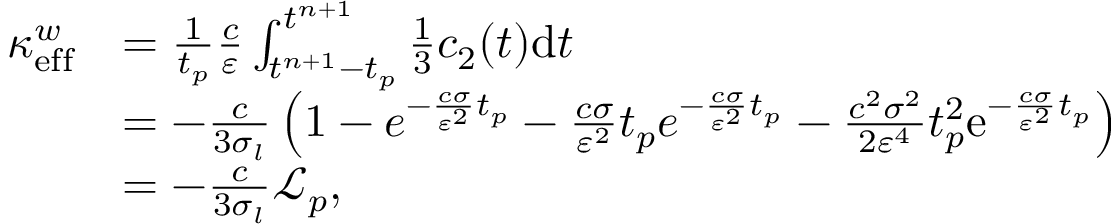Convert formula to latex. <formula><loc_0><loc_0><loc_500><loc_500>\begin{array} { r l } { \kappa _ { e f f } ^ { w } } & { = \frac { 1 } { t _ { p } } \frac { c } { \varepsilon } \int _ { t ^ { n + 1 } - t _ { p } } ^ { t ^ { n + 1 } } \frac { 1 } { 3 } c _ { 2 } ( t ) d t } \\ & { = - \frac { c } { 3 \sigma _ { l } } \left ( 1 - e ^ { - \frac { c \sigma } { \varepsilon ^ { 2 } } t _ { p } } - \frac { c \sigma } { \varepsilon ^ { 2 } } t _ { p } e ^ { - \frac { c \sigma } { \varepsilon ^ { 2 } } t _ { p } } - \frac { c ^ { 2 } \sigma ^ { 2 } } { 2 \varepsilon ^ { 4 } } t _ { p } ^ { 2 } e ^ { - \frac { c \sigma } { \varepsilon ^ { 2 } } t _ { p } } \right ) } \\ & { = - \frac { c } { 3 \sigma _ { l } } \mathcal { L } _ { p } , } \end{array}</formula> 